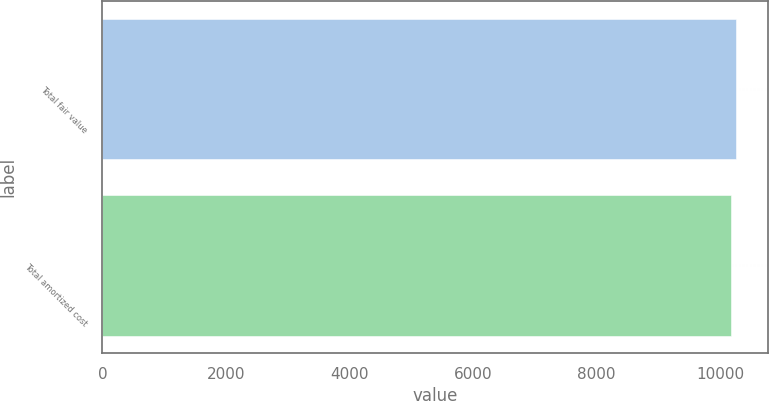Convert chart. <chart><loc_0><loc_0><loc_500><loc_500><bar_chart><fcel>Total fair value<fcel>Total amortized cost<nl><fcel>10258<fcel>10168<nl></chart> 